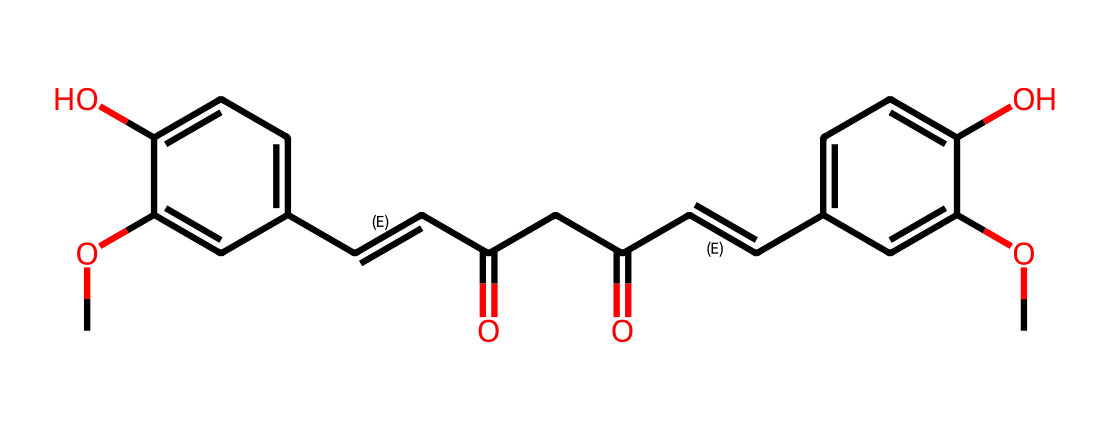What is the molecular formula of curcumin? By analyzing the SMILES representation, we identify the number of carbon (C), hydrogen (H), and oxygen (O) atoms present. Counting carefully, we find that curcumin has 21 carbons, 20 hydrogens, and 6 oxygens. Therefore, the molecular formula is C21H20O6.
Answer: C21H20O6 How many hydroxyl (–OH) groups are present in curcumin? The chemical structure shows two hydroxyl groups, which are indicated by -OH symbols in the structure. Hence, there are two -OH groups present.
Answer: 2 What is the total number of double bonds in curcumin? Reviewing the SMILES representation, we notice that the structure contains three double bonds indicated by the presence of "=" signs between carbon atoms. This gives a total count of three double bonds in curcumin.
Answer: 3 Is curcumin classified as a polar or non-polar compound? The presence of multiple hydroxyl groups and carbonyls in curcumin indicates it has polar characteristics due to the capability of hydrogen bonding and higher electronegativity of oxygen compared to carbon. Therefore, curcumin can be classified as polar.
Answer: polar What type of chemical is curcumin categorized as? Based on its structure and properties, curcumin is recognized as a non-electrolyte because it does not dissociate into ions when dissolved in water, a characteristic typical of many organic compounds including those containing no charged groups.
Answer: non-electrolyte What functional groups are prominently featured in curcumin? By analyzing the SMILES structure, we identify the presence of phenolic (–OH) groups, double bonds, and carbonyl (–C=O) groups, which are key functional groups that define curcumin's reactivity and interactions.
Answer: phenolic, double bond, carbonyl 